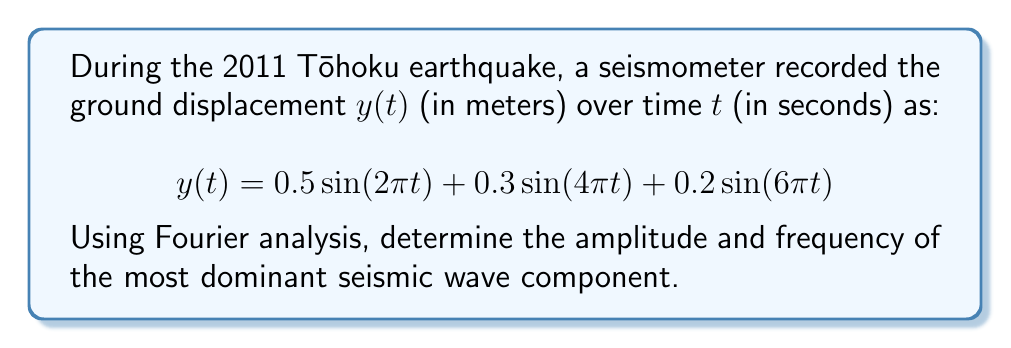Show me your answer to this math problem. To analyze the frequency and amplitude of seismic waves using Fourier analysis, we need to identify the components of the given function:

1) The general form of a sinusoidal function is $A\sin(2\pi ft)$, where $A$ is the amplitude and $f$ is the frequency.

2) Breaking down the given function:
   
   $$y(t) = 0.5\sin(2\pi t) + 0.3\sin(4\pi t) + 0.2\sin(6\pi t)$$

3) For the first term: $0.5\sin(2\pi t)$
   Amplitude $A_1 = 0.5$
   Frequency $f_1 = 1$ Hz (as $2\pi t = 2\pi f_1t$)

4) For the second term: $0.3\sin(4\pi t)$
   Amplitude $A_2 = 0.3$
   Frequency $f_2 = 2$ Hz (as $4\pi t = 2\pi(2t) = 2\pi f_2t$)

5) For the third term: $0.2\sin(6\pi t)$
   Amplitude $A_3 = 0.2$
   Frequency $f_3 = 3$ Hz (as $6\pi t = 2\pi(3t) = 2\pi f_3t$)

6) The most dominant wave component is the one with the largest amplitude.

7) Comparing amplitudes: $0.5 > 0.3 > 0.2$

Therefore, the most dominant seismic wave component has an amplitude of 0.5 meters and a frequency of 1 Hz.
Answer: Amplitude: 0.5 m, Frequency: 1 Hz 